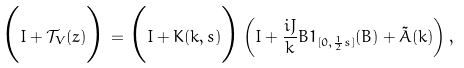<formula> <loc_0><loc_0><loc_500><loc_500>\Big { ( } I + \mathcal { T } _ { V } ( z ) \Big { ) } = \Big { ( } I + K ( k , s ) \Big { ) } \left ( I + \frac { i J } { k } B 1 _ { [ 0 , \frac { 1 } { 2 } s ] } ( B ) + \tilde { A } ( k ) \right ) ,</formula> 